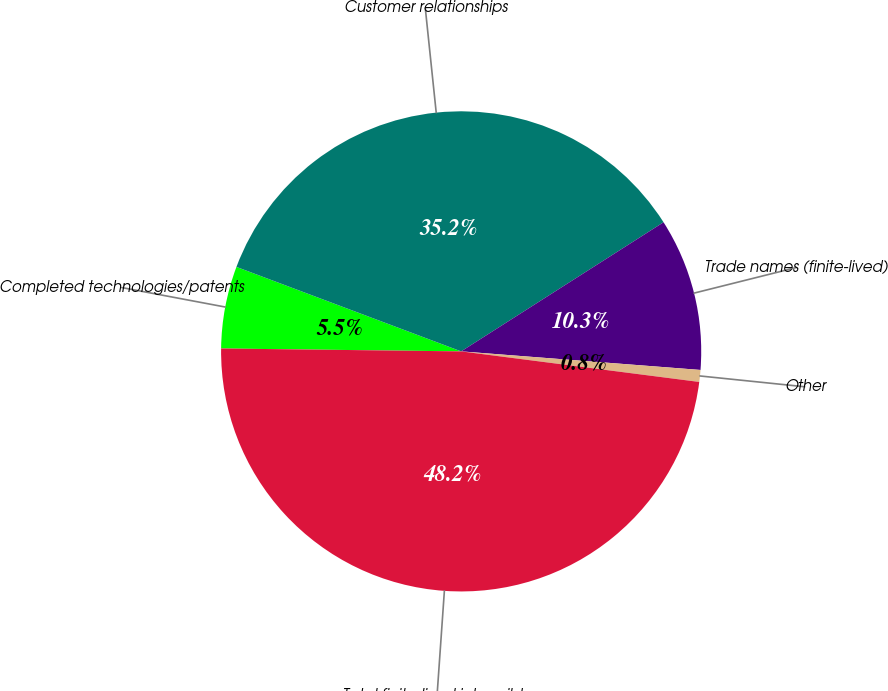Convert chart. <chart><loc_0><loc_0><loc_500><loc_500><pie_chart><fcel>Completed technologies/patents<fcel>Customer relationships<fcel>Trade names (finite-lived)<fcel>Other<fcel>Total finite-lived intangible<nl><fcel>5.53%<fcel>35.24%<fcel>10.27%<fcel>0.8%<fcel>48.16%<nl></chart> 